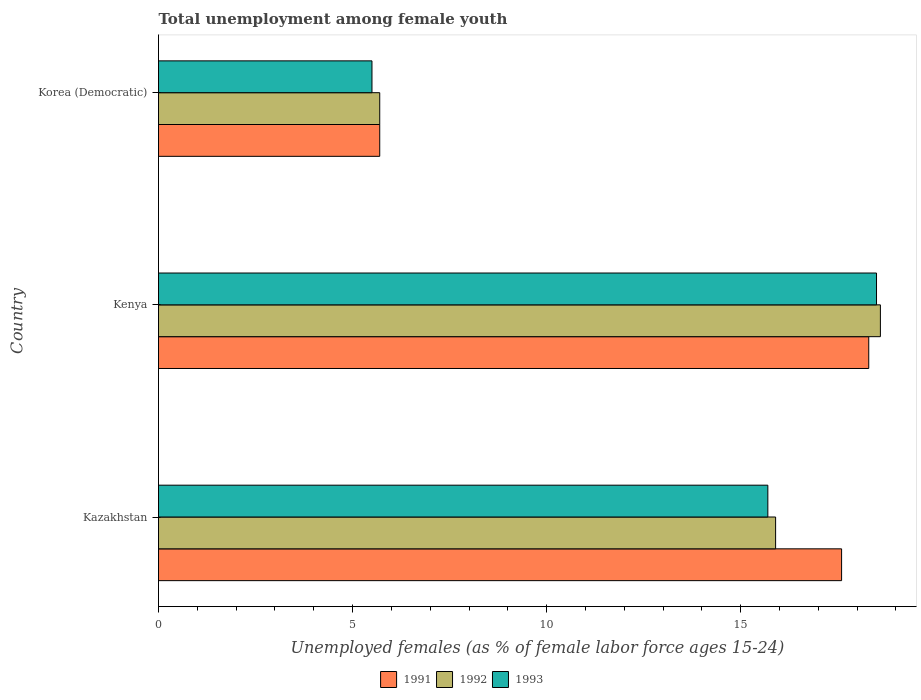How many different coloured bars are there?
Make the answer very short. 3. How many groups of bars are there?
Provide a succinct answer. 3. What is the label of the 1st group of bars from the top?
Your answer should be very brief. Korea (Democratic). What is the percentage of unemployed females in in 1992 in Kenya?
Give a very brief answer. 18.6. Across all countries, what is the maximum percentage of unemployed females in in 1991?
Ensure brevity in your answer.  18.3. Across all countries, what is the minimum percentage of unemployed females in in 1993?
Make the answer very short. 5.5. In which country was the percentage of unemployed females in in 1993 maximum?
Give a very brief answer. Kenya. In which country was the percentage of unemployed females in in 1993 minimum?
Offer a terse response. Korea (Democratic). What is the total percentage of unemployed females in in 1991 in the graph?
Make the answer very short. 41.6. What is the difference between the percentage of unemployed females in in 1993 in Korea (Democratic) and the percentage of unemployed females in in 1992 in Kazakhstan?
Your answer should be very brief. -10.4. What is the average percentage of unemployed females in in 1993 per country?
Your response must be concise. 13.23. What is the difference between the percentage of unemployed females in in 1991 and percentage of unemployed females in in 1993 in Kazakhstan?
Offer a very short reply. 1.9. In how many countries, is the percentage of unemployed females in in 1993 greater than 5 %?
Your response must be concise. 3. What is the ratio of the percentage of unemployed females in in 1993 in Kazakhstan to that in Kenya?
Ensure brevity in your answer.  0.85. Is the difference between the percentage of unemployed females in in 1991 in Kazakhstan and Kenya greater than the difference between the percentage of unemployed females in in 1993 in Kazakhstan and Kenya?
Offer a very short reply. Yes. What is the difference between the highest and the second highest percentage of unemployed females in in 1993?
Your answer should be very brief. 2.8. What is the difference between the highest and the lowest percentage of unemployed females in in 1991?
Your response must be concise. 12.6. Is the sum of the percentage of unemployed females in in 1993 in Kazakhstan and Korea (Democratic) greater than the maximum percentage of unemployed females in in 1992 across all countries?
Provide a succinct answer. Yes. How many bars are there?
Ensure brevity in your answer.  9. How many countries are there in the graph?
Ensure brevity in your answer.  3. What is the difference between two consecutive major ticks on the X-axis?
Offer a terse response. 5. Where does the legend appear in the graph?
Ensure brevity in your answer.  Bottom center. How are the legend labels stacked?
Your response must be concise. Horizontal. What is the title of the graph?
Make the answer very short. Total unemployment among female youth. Does "1962" appear as one of the legend labels in the graph?
Keep it short and to the point. No. What is the label or title of the X-axis?
Your response must be concise. Unemployed females (as % of female labor force ages 15-24). What is the Unemployed females (as % of female labor force ages 15-24) of 1991 in Kazakhstan?
Ensure brevity in your answer.  17.6. What is the Unemployed females (as % of female labor force ages 15-24) of 1992 in Kazakhstan?
Your response must be concise. 15.9. What is the Unemployed females (as % of female labor force ages 15-24) of 1993 in Kazakhstan?
Provide a succinct answer. 15.7. What is the Unemployed females (as % of female labor force ages 15-24) of 1991 in Kenya?
Your response must be concise. 18.3. What is the Unemployed females (as % of female labor force ages 15-24) of 1992 in Kenya?
Give a very brief answer. 18.6. What is the Unemployed females (as % of female labor force ages 15-24) in 1993 in Kenya?
Your response must be concise. 18.5. What is the Unemployed females (as % of female labor force ages 15-24) in 1991 in Korea (Democratic)?
Ensure brevity in your answer.  5.7. What is the Unemployed females (as % of female labor force ages 15-24) in 1992 in Korea (Democratic)?
Offer a very short reply. 5.7. What is the Unemployed females (as % of female labor force ages 15-24) in 1993 in Korea (Democratic)?
Your response must be concise. 5.5. Across all countries, what is the maximum Unemployed females (as % of female labor force ages 15-24) of 1991?
Offer a terse response. 18.3. Across all countries, what is the maximum Unemployed females (as % of female labor force ages 15-24) in 1992?
Provide a short and direct response. 18.6. Across all countries, what is the maximum Unemployed females (as % of female labor force ages 15-24) of 1993?
Your answer should be compact. 18.5. Across all countries, what is the minimum Unemployed females (as % of female labor force ages 15-24) in 1991?
Provide a short and direct response. 5.7. Across all countries, what is the minimum Unemployed females (as % of female labor force ages 15-24) in 1992?
Ensure brevity in your answer.  5.7. Across all countries, what is the minimum Unemployed females (as % of female labor force ages 15-24) in 1993?
Keep it short and to the point. 5.5. What is the total Unemployed females (as % of female labor force ages 15-24) of 1991 in the graph?
Provide a short and direct response. 41.6. What is the total Unemployed females (as % of female labor force ages 15-24) of 1992 in the graph?
Provide a succinct answer. 40.2. What is the total Unemployed females (as % of female labor force ages 15-24) of 1993 in the graph?
Make the answer very short. 39.7. What is the difference between the Unemployed females (as % of female labor force ages 15-24) of 1991 in Kazakhstan and that in Kenya?
Provide a short and direct response. -0.7. What is the difference between the Unemployed females (as % of female labor force ages 15-24) of 1993 in Kazakhstan and that in Korea (Democratic)?
Provide a short and direct response. 10.2. What is the difference between the Unemployed females (as % of female labor force ages 15-24) of 1991 in Kenya and that in Korea (Democratic)?
Make the answer very short. 12.6. What is the difference between the Unemployed females (as % of female labor force ages 15-24) of 1993 in Kenya and that in Korea (Democratic)?
Your response must be concise. 13. What is the difference between the Unemployed females (as % of female labor force ages 15-24) in 1991 in Kazakhstan and the Unemployed females (as % of female labor force ages 15-24) in 1992 in Kenya?
Provide a short and direct response. -1. What is the difference between the Unemployed females (as % of female labor force ages 15-24) in 1991 in Kazakhstan and the Unemployed females (as % of female labor force ages 15-24) in 1992 in Korea (Democratic)?
Your answer should be very brief. 11.9. What is the difference between the Unemployed females (as % of female labor force ages 15-24) in 1991 in Kenya and the Unemployed females (as % of female labor force ages 15-24) in 1993 in Korea (Democratic)?
Your answer should be compact. 12.8. What is the average Unemployed females (as % of female labor force ages 15-24) in 1991 per country?
Offer a very short reply. 13.87. What is the average Unemployed females (as % of female labor force ages 15-24) in 1992 per country?
Offer a very short reply. 13.4. What is the average Unemployed females (as % of female labor force ages 15-24) of 1993 per country?
Offer a very short reply. 13.23. What is the difference between the Unemployed females (as % of female labor force ages 15-24) in 1991 and Unemployed females (as % of female labor force ages 15-24) in 1992 in Kenya?
Your answer should be very brief. -0.3. What is the difference between the Unemployed females (as % of female labor force ages 15-24) of 1991 and Unemployed females (as % of female labor force ages 15-24) of 1993 in Kenya?
Keep it short and to the point. -0.2. What is the difference between the Unemployed females (as % of female labor force ages 15-24) in 1992 and Unemployed females (as % of female labor force ages 15-24) in 1993 in Kenya?
Offer a terse response. 0.1. What is the difference between the Unemployed females (as % of female labor force ages 15-24) in 1991 and Unemployed females (as % of female labor force ages 15-24) in 1993 in Korea (Democratic)?
Give a very brief answer. 0.2. What is the difference between the Unemployed females (as % of female labor force ages 15-24) of 1992 and Unemployed females (as % of female labor force ages 15-24) of 1993 in Korea (Democratic)?
Your answer should be compact. 0.2. What is the ratio of the Unemployed females (as % of female labor force ages 15-24) of 1991 in Kazakhstan to that in Kenya?
Your answer should be compact. 0.96. What is the ratio of the Unemployed females (as % of female labor force ages 15-24) of 1992 in Kazakhstan to that in Kenya?
Offer a terse response. 0.85. What is the ratio of the Unemployed females (as % of female labor force ages 15-24) in 1993 in Kazakhstan to that in Kenya?
Your response must be concise. 0.85. What is the ratio of the Unemployed females (as % of female labor force ages 15-24) in 1991 in Kazakhstan to that in Korea (Democratic)?
Make the answer very short. 3.09. What is the ratio of the Unemployed females (as % of female labor force ages 15-24) in 1992 in Kazakhstan to that in Korea (Democratic)?
Ensure brevity in your answer.  2.79. What is the ratio of the Unemployed females (as % of female labor force ages 15-24) in 1993 in Kazakhstan to that in Korea (Democratic)?
Offer a very short reply. 2.85. What is the ratio of the Unemployed females (as % of female labor force ages 15-24) of 1991 in Kenya to that in Korea (Democratic)?
Your response must be concise. 3.21. What is the ratio of the Unemployed females (as % of female labor force ages 15-24) in 1992 in Kenya to that in Korea (Democratic)?
Keep it short and to the point. 3.26. What is the ratio of the Unemployed females (as % of female labor force ages 15-24) of 1993 in Kenya to that in Korea (Democratic)?
Your answer should be very brief. 3.36. What is the difference between the highest and the second highest Unemployed females (as % of female labor force ages 15-24) in 1992?
Your answer should be compact. 2.7. What is the difference between the highest and the second highest Unemployed females (as % of female labor force ages 15-24) in 1993?
Offer a very short reply. 2.8. What is the difference between the highest and the lowest Unemployed females (as % of female labor force ages 15-24) in 1991?
Your answer should be compact. 12.6. What is the difference between the highest and the lowest Unemployed females (as % of female labor force ages 15-24) in 1993?
Provide a short and direct response. 13. 